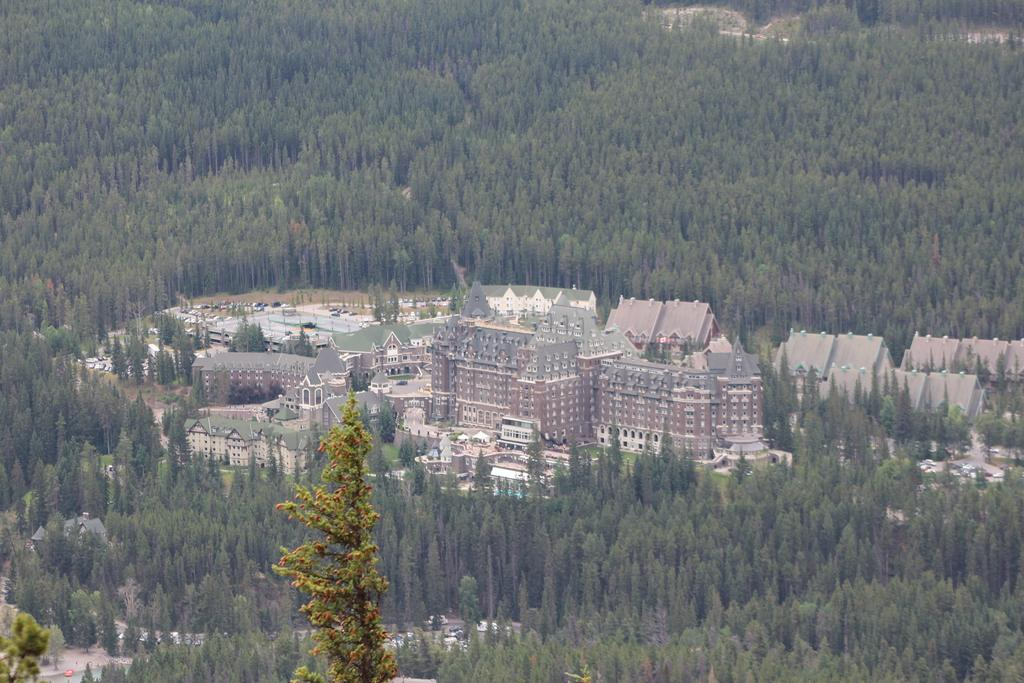What type of natural elements are present in the image? There are many trees and plants in the image. What is the main man-made structure in the image? There is a fort in the middle of the image. Can you describe the fort's features? The fort has walls and a roof. From where might the image have been taken? The image appears to be taken from a high vantage point, possibly a plane. Is there a volcano erupting in the image? No, there is no volcano present in the image. What type of experience can be gained from visiting the fort in the image? The question is irrelevant to the image, as it does not address any of the visible elements or features. 